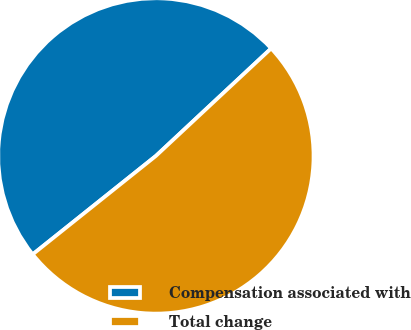Convert chart. <chart><loc_0><loc_0><loc_500><loc_500><pie_chart><fcel>Compensation associated with<fcel>Total change<nl><fcel>48.78%<fcel>51.22%<nl></chart> 